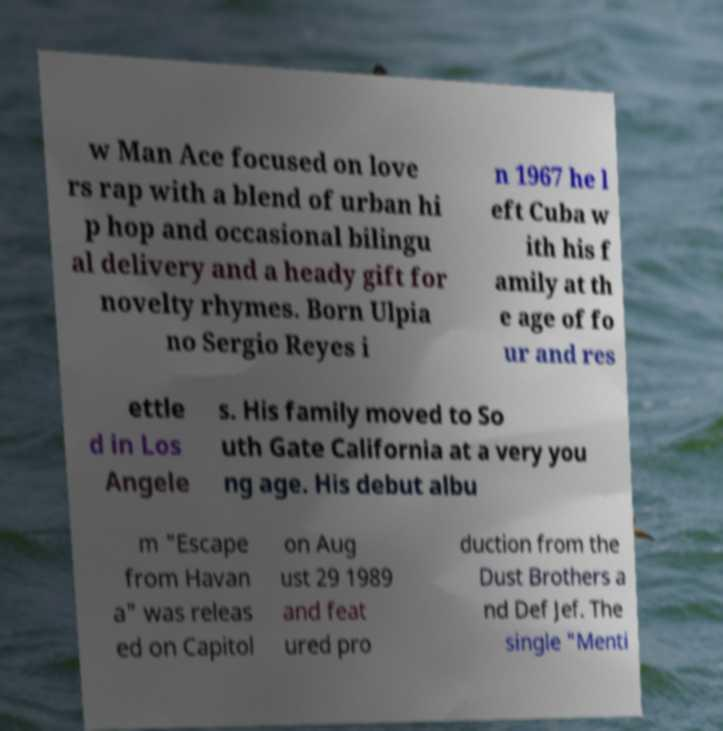There's text embedded in this image that I need extracted. Can you transcribe it verbatim? w Man Ace focused on love rs rap with a blend of urban hi p hop and occasional bilingu al delivery and a heady gift for novelty rhymes. Born Ulpia no Sergio Reyes i n 1967 he l eft Cuba w ith his f amily at th e age of fo ur and res ettle d in Los Angele s. His family moved to So uth Gate California at a very you ng age. His debut albu m "Escape from Havan a" was releas ed on Capitol on Aug ust 29 1989 and feat ured pro duction from the Dust Brothers a nd Def Jef. The single "Menti 